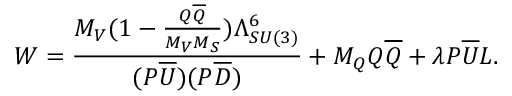Convert formula to latex. <formula><loc_0><loc_0><loc_500><loc_500>W = \frac { M _ { V } ( 1 - \frac { Q \overline { Q } } { M _ { V } M _ { S } } ) \Lambda _ { S U ( 3 ) } ^ { 6 } } { ( P \overline { U } ) ( P \overline { D } ) } + M _ { Q } Q \overline { Q } + \lambda P \overline { U } L .</formula> 